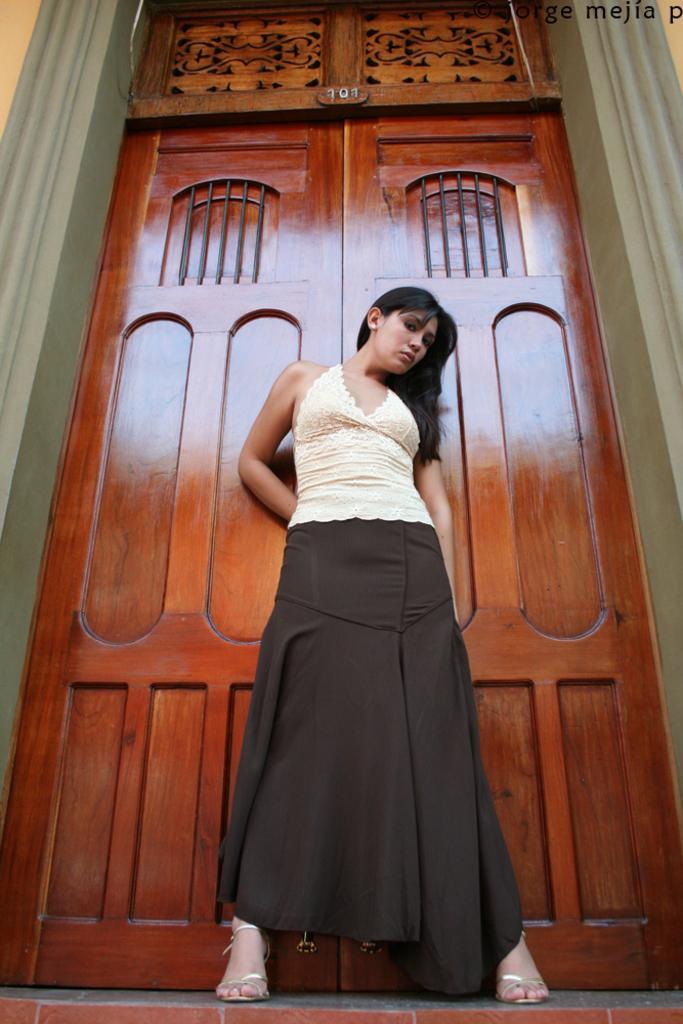Please provide a concise description of this image. In this image, in the middle, we can see a woman standing. In the background, we can see a door which is closed. 